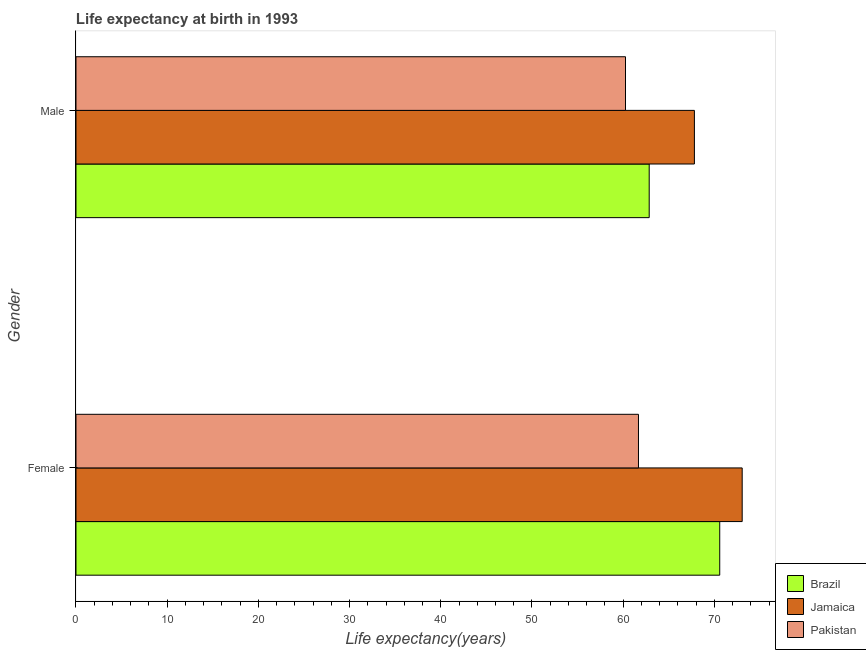How many different coloured bars are there?
Ensure brevity in your answer.  3. How many groups of bars are there?
Provide a succinct answer. 2. How many bars are there on the 1st tick from the bottom?
Your answer should be very brief. 3. What is the life expectancy(male) in Pakistan?
Provide a short and direct response. 60.26. Across all countries, what is the maximum life expectancy(female)?
Your answer should be very brief. 73.05. Across all countries, what is the minimum life expectancy(female)?
Keep it short and to the point. 61.68. In which country was the life expectancy(female) maximum?
Your answer should be compact. Jamaica. In which country was the life expectancy(female) minimum?
Your answer should be very brief. Pakistan. What is the total life expectancy(male) in the graph?
Provide a short and direct response. 190.92. What is the difference between the life expectancy(male) in Pakistan and that in Brazil?
Ensure brevity in your answer.  -2.6. What is the difference between the life expectancy(female) in Pakistan and the life expectancy(male) in Jamaica?
Provide a succinct answer. -6.13. What is the average life expectancy(male) per country?
Ensure brevity in your answer.  63.64. What is the difference between the life expectancy(female) and life expectancy(male) in Pakistan?
Offer a very short reply. 1.42. In how many countries, is the life expectancy(female) greater than 26 years?
Your answer should be compact. 3. What is the ratio of the life expectancy(female) in Pakistan to that in Brazil?
Provide a short and direct response. 0.87. In how many countries, is the life expectancy(female) greater than the average life expectancy(female) taken over all countries?
Offer a very short reply. 2. Are the values on the major ticks of X-axis written in scientific E-notation?
Provide a short and direct response. No. Does the graph contain any zero values?
Provide a short and direct response. No. Where does the legend appear in the graph?
Your response must be concise. Bottom right. How many legend labels are there?
Your response must be concise. 3. What is the title of the graph?
Your response must be concise. Life expectancy at birth in 1993. What is the label or title of the X-axis?
Ensure brevity in your answer.  Life expectancy(years). What is the Life expectancy(years) in Brazil in Female?
Your response must be concise. 70.59. What is the Life expectancy(years) of Jamaica in Female?
Offer a terse response. 73.05. What is the Life expectancy(years) in Pakistan in Female?
Ensure brevity in your answer.  61.68. What is the Life expectancy(years) in Brazil in Male?
Provide a short and direct response. 62.85. What is the Life expectancy(years) of Jamaica in Male?
Give a very brief answer. 67.81. What is the Life expectancy(years) in Pakistan in Male?
Offer a terse response. 60.26. Across all Gender, what is the maximum Life expectancy(years) of Brazil?
Offer a terse response. 70.59. Across all Gender, what is the maximum Life expectancy(years) in Jamaica?
Make the answer very short. 73.05. Across all Gender, what is the maximum Life expectancy(years) in Pakistan?
Offer a very short reply. 61.68. Across all Gender, what is the minimum Life expectancy(years) in Brazil?
Make the answer very short. 62.85. Across all Gender, what is the minimum Life expectancy(years) of Jamaica?
Your answer should be compact. 67.81. Across all Gender, what is the minimum Life expectancy(years) of Pakistan?
Your response must be concise. 60.26. What is the total Life expectancy(years) in Brazil in the graph?
Your answer should be very brief. 133.44. What is the total Life expectancy(years) in Jamaica in the graph?
Provide a succinct answer. 140.86. What is the total Life expectancy(years) of Pakistan in the graph?
Keep it short and to the point. 121.94. What is the difference between the Life expectancy(years) of Brazil in Female and that in Male?
Your response must be concise. 7.73. What is the difference between the Life expectancy(years) of Jamaica in Female and that in Male?
Your answer should be very brief. 5.24. What is the difference between the Life expectancy(years) of Pakistan in Female and that in Male?
Keep it short and to the point. 1.42. What is the difference between the Life expectancy(years) in Brazil in Female and the Life expectancy(years) in Jamaica in Male?
Keep it short and to the point. 2.78. What is the difference between the Life expectancy(years) of Brazil in Female and the Life expectancy(years) of Pakistan in Male?
Offer a terse response. 10.33. What is the difference between the Life expectancy(years) of Jamaica in Female and the Life expectancy(years) of Pakistan in Male?
Your answer should be very brief. 12.79. What is the average Life expectancy(years) of Brazil per Gender?
Keep it short and to the point. 66.72. What is the average Life expectancy(years) in Jamaica per Gender?
Provide a short and direct response. 70.43. What is the average Life expectancy(years) of Pakistan per Gender?
Ensure brevity in your answer.  60.97. What is the difference between the Life expectancy(years) of Brazil and Life expectancy(years) of Jamaica in Female?
Your response must be concise. -2.46. What is the difference between the Life expectancy(years) of Brazil and Life expectancy(years) of Pakistan in Female?
Your answer should be very brief. 8.91. What is the difference between the Life expectancy(years) in Jamaica and Life expectancy(years) in Pakistan in Female?
Keep it short and to the point. 11.37. What is the difference between the Life expectancy(years) in Brazil and Life expectancy(years) in Jamaica in Male?
Provide a succinct answer. -4.96. What is the difference between the Life expectancy(years) of Brazil and Life expectancy(years) of Pakistan in Male?
Your answer should be compact. 2.6. What is the difference between the Life expectancy(years) of Jamaica and Life expectancy(years) of Pakistan in Male?
Provide a short and direct response. 7.55. What is the ratio of the Life expectancy(years) in Brazil in Female to that in Male?
Your answer should be compact. 1.12. What is the ratio of the Life expectancy(years) in Jamaica in Female to that in Male?
Offer a very short reply. 1.08. What is the ratio of the Life expectancy(years) of Pakistan in Female to that in Male?
Ensure brevity in your answer.  1.02. What is the difference between the highest and the second highest Life expectancy(years) in Brazil?
Keep it short and to the point. 7.73. What is the difference between the highest and the second highest Life expectancy(years) of Jamaica?
Give a very brief answer. 5.24. What is the difference between the highest and the second highest Life expectancy(years) of Pakistan?
Your answer should be compact. 1.42. What is the difference between the highest and the lowest Life expectancy(years) in Brazil?
Provide a short and direct response. 7.73. What is the difference between the highest and the lowest Life expectancy(years) in Jamaica?
Provide a short and direct response. 5.24. What is the difference between the highest and the lowest Life expectancy(years) of Pakistan?
Your response must be concise. 1.42. 